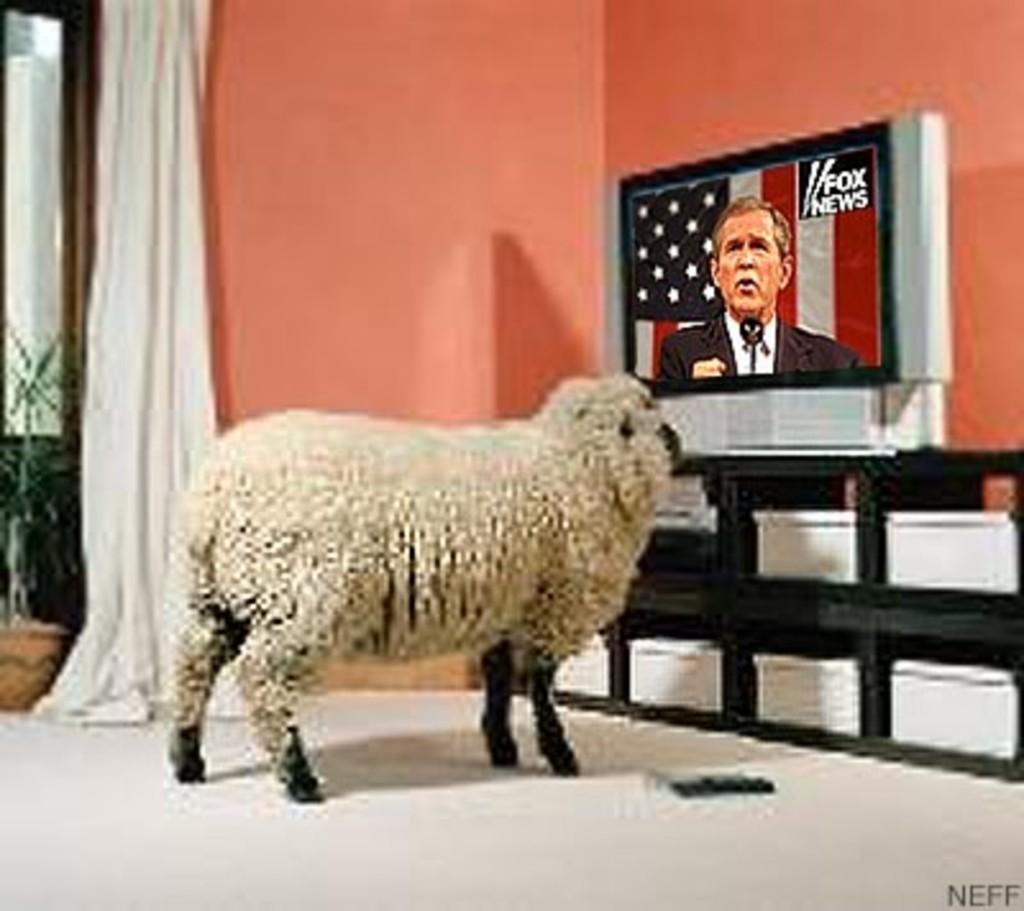Describe this image in one or two sentences. We can able to see a sheep, curtain and television. This television is on a rack. 